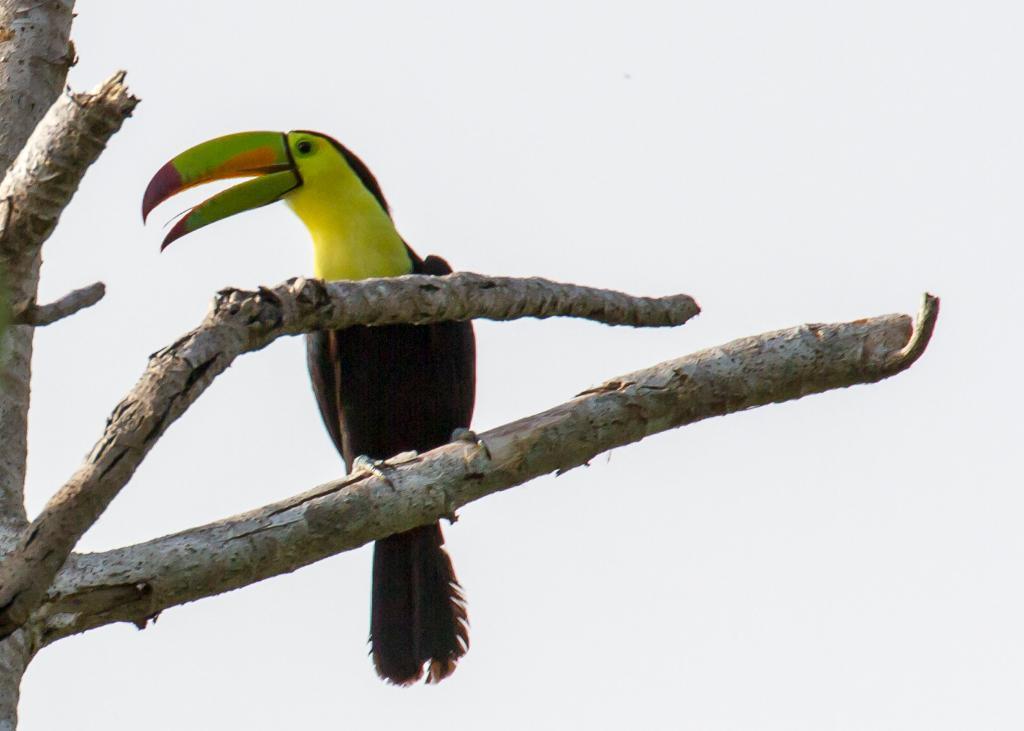Please provide a concise description of this image. In the image there is a bird sitting on the branch of a tree. 